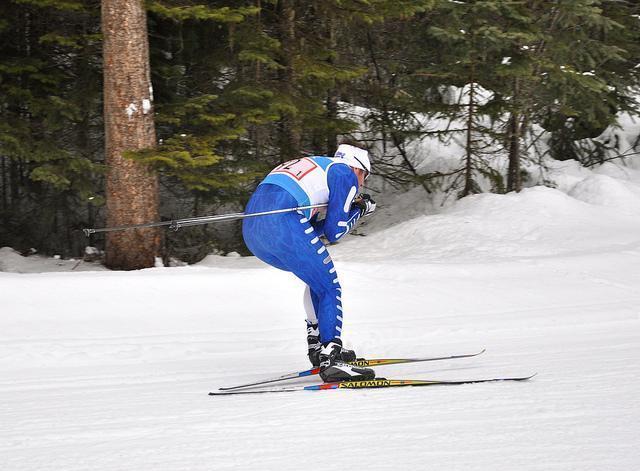How many red bikes are there?
Give a very brief answer. 0. 